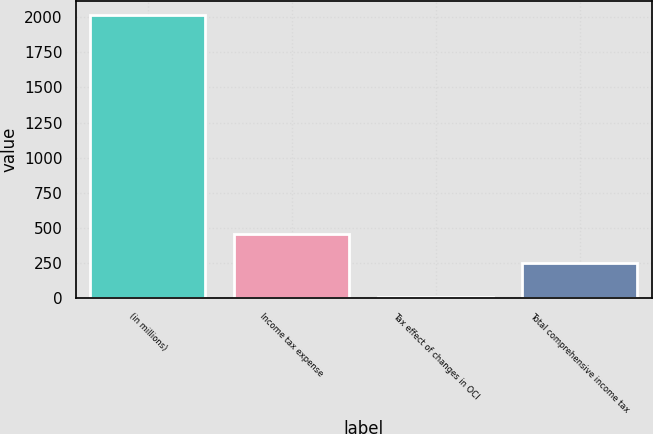Convert chart to OTSL. <chart><loc_0><loc_0><loc_500><loc_500><bar_chart><fcel>(in millions)<fcel>Income tax expense<fcel>Tax effect of changes in OCI<fcel>Total comprehensive income tax<nl><fcel>2017<fcel>454<fcel>7<fcel>253<nl></chart> 